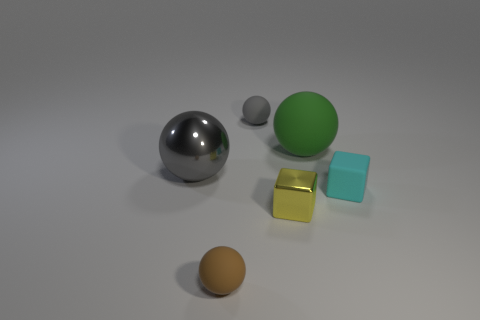The thing that is both in front of the tiny gray rubber thing and behind the large gray metal thing is made of what material?
Provide a succinct answer. Rubber. The gray rubber object is what size?
Provide a succinct answer. Small. What color is the other tiny rubber object that is the same shape as the small gray matte object?
Provide a short and direct response. Brown. Is there any other thing that is the same color as the big metal ball?
Make the answer very short. Yes. There is a shiny object that is in front of the large gray sphere; is it the same size as the gray sphere that is on the right side of the brown matte ball?
Make the answer very short. Yes. Is the number of large rubber objects behind the large matte sphere the same as the number of large objects that are to the left of the brown rubber thing?
Your answer should be very brief. No. There is a cyan block; does it have the same size as the matte ball that is in front of the cyan object?
Provide a succinct answer. Yes. Is there a small gray thing on the right side of the block on the right side of the yellow block?
Your answer should be very brief. No. Is there a metal thing that has the same shape as the cyan rubber object?
Give a very brief answer. Yes. There is a tiny ball in front of the matte thing to the right of the big green thing; how many brown matte spheres are left of it?
Offer a terse response. 0. 